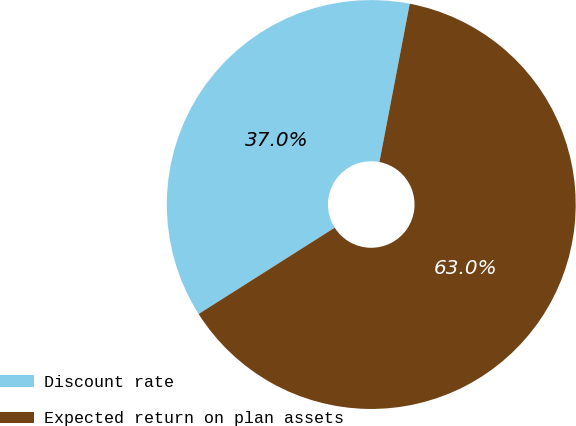Convert chart. <chart><loc_0><loc_0><loc_500><loc_500><pie_chart><fcel>Discount rate<fcel>Expected return on plan assets<nl><fcel>37.01%<fcel>62.99%<nl></chart> 